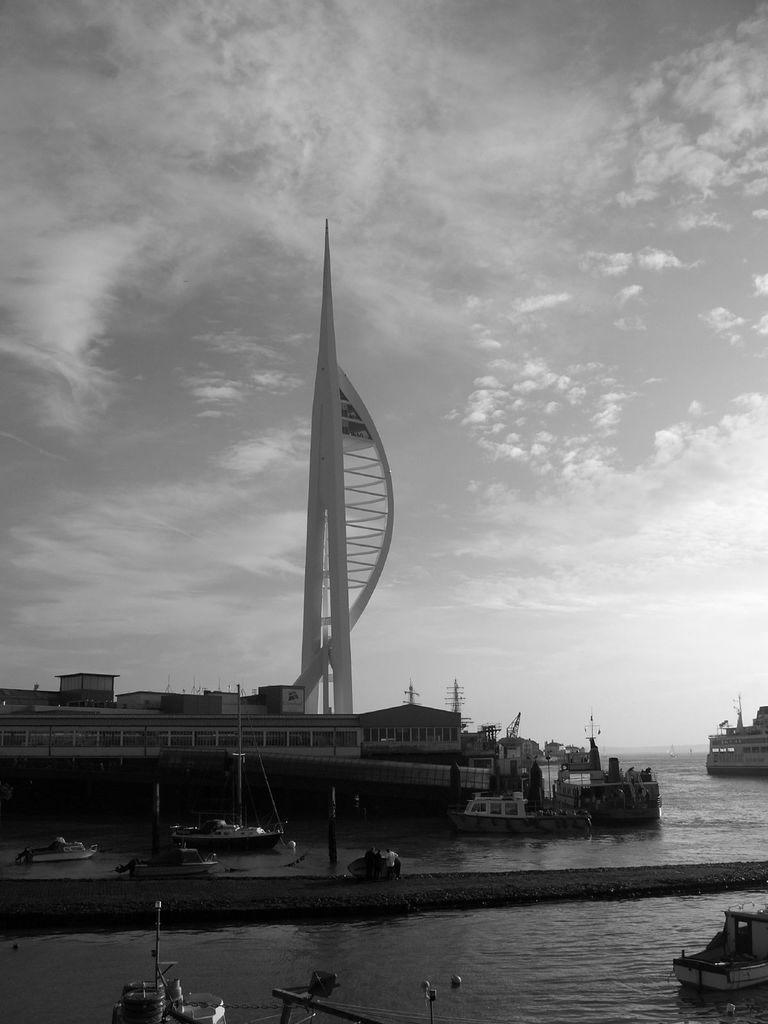What type of structure is visible in the picture? There is a building in the picture. What natural feature can be seen in the picture? There is an ocean in the picture. What types of watercraft are present in the picture? There are boats and ships in the picture. What architectural feature can be observed on the building? The building has a tower. What is the condition of the sky in the picture? The sky is clear in the picture. Can you tell me how many plastic beads are floating in the ocean in the image? There are no plastic beads visible in the image; it features a building, an ocean, boats, ships, and a clear sky. Is there a volleyball game taking place on the beach in the image? There is no beach or volleyball game present in the image. 